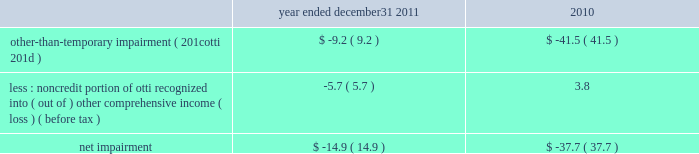Net impairment we recognized $ 14.9 million of net impairment during the year ended december 31 , 2011 , on certain securities in our non-agency cmo portfolio due to continued deterioration in the expected credit performance of the underlying loans in those specific securities .
The gross other-than-temporary impairment ( 201cotti 201d ) and the noncredit portion of otti , which was or had been previously recorded through other comprehensive income , are shown in the table below ( dollars in millions ) : year ended december 31 , 2011 2010 .
Other revenues other revenues decreased 15% ( 15 % ) to $ 39.3 million for the year ended december 31 , 2011 compared to 2010 .
The decrease was due primarily to the gain on sale of approximately $ 1 billion in savings accounts to discover financial services in the first quarter of 2010 , which increased other revenues during the year ended december 31 , 2010 .
Provision for loan losses provision for loan losses decreased 43% ( 43 % ) to $ 440.6 million for the year ended december 31 , 2011 compared to 2010 .
The decrease in provision for loan losses was driven by improving credit trends and loan portfolio run-off , as evidenced by the lower levels of delinquent loans in the one- to four-family and home equity loan portfolios .
The provision for loan losses has declined for three consecutive years , down 72% ( 72 % ) from its peak of $ 1.6 billion for the year ended december 31 , 2008 .
We expect provision for loan losses to continue to decline in 2012 compared to 2011 , although it is subject to variability from quarter to quarter .
As we transition from the ots to the occ , we are evaluating programs and practices that were designed in accordance with guidance from the ots .
We are working to align certain policies and procedures to the guidance from the occ and have suspended certain loan modification programs that will require changes .
We increased the qualitative reserve in 2011 to reflect additional estimated losses during the period of reduced activity in our modification programs , as well as uncertainty around certain loans modified under our previous programs .
Once the evaluation of the existing programs and practices is complete and any necessary changes have been implemented , we will re-assess the overall qualitative reserve. .
As december 312011 what was the amount of the provision for impairment in billion? 
Rationale: as december 312011 the amount of the provision for impairment in billion was 1.152 compared to 1.6 in 2008
Computations: (1.6 * 72%)
Answer: 1.152. 